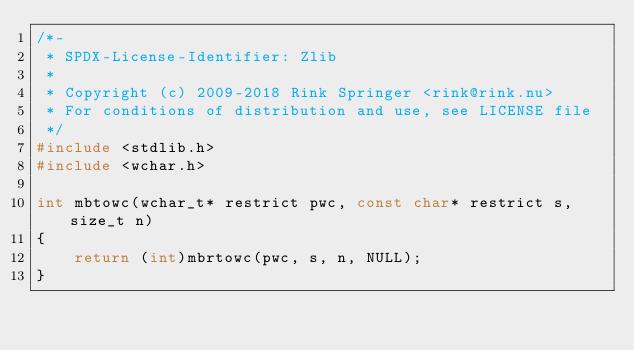<code> <loc_0><loc_0><loc_500><loc_500><_C_>/*-
 * SPDX-License-Identifier: Zlib
 *
 * Copyright (c) 2009-2018 Rink Springer <rink@rink.nu>
 * For conditions of distribution and use, see LICENSE file
 */
#include <stdlib.h>
#include <wchar.h>

int mbtowc(wchar_t* restrict pwc, const char* restrict s, size_t n)
{
    return (int)mbrtowc(pwc, s, n, NULL);
}
</code> 